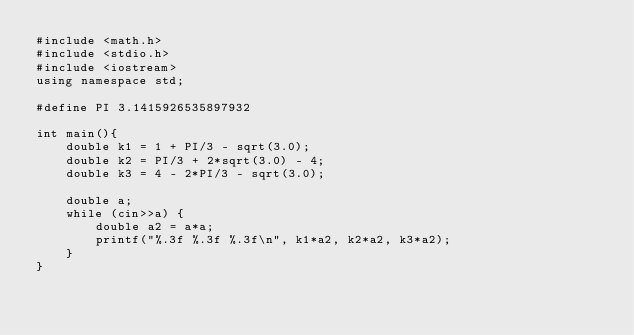<code> <loc_0><loc_0><loc_500><loc_500><_C++_>#include <math.h>
#include <stdio.h>
#include <iostream>
using namespace std;

#define PI 3.1415926535897932

int main(){
    double k1 = 1 + PI/3 - sqrt(3.0);
    double k2 = PI/3 + 2*sqrt(3.0) - 4;
    double k3 = 4 - 2*PI/3 - sqrt(3.0);

    double a;
    while (cin>>a) {
        double a2 = a*a;
        printf("%.3f %.3f %.3f\n", k1*a2, k2*a2, k3*a2);
    }
}

</code> 